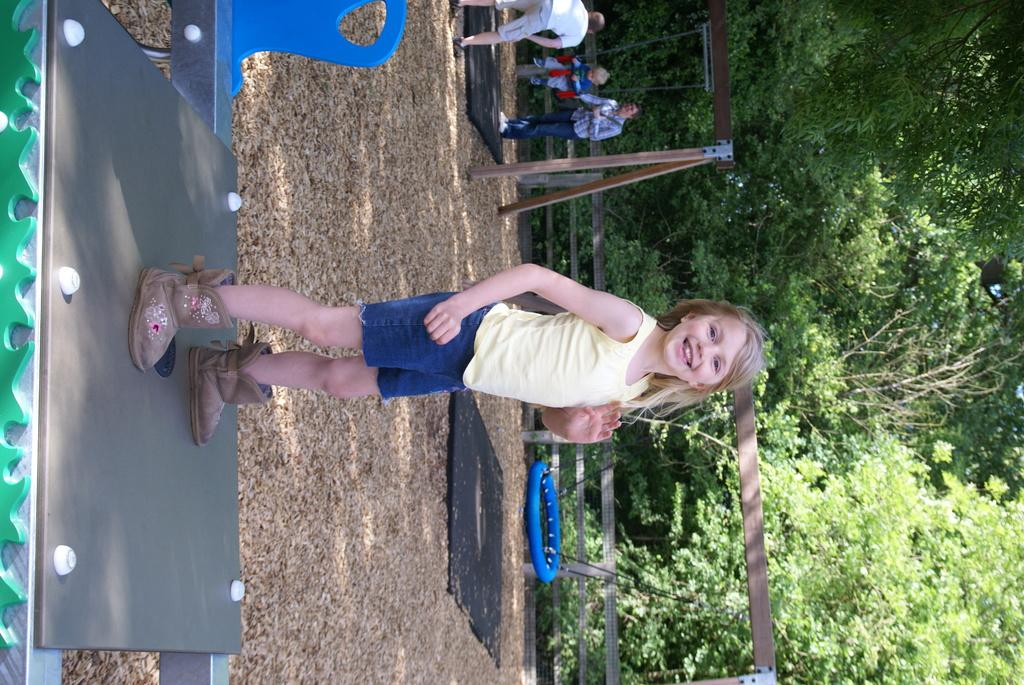What is the girl doing in the image? The girl is standing on a platform in the image. What can be seen in the background behind the girl? A: In the background, there is a fence, people, trees, and swings. Can you describe the setting of the image? The girl is standing on a platform, and there are various elements in the background, including a fence, people, trees, and swings, suggesting an outdoor recreational area. How much payment is required to use the bucket in the image? There is no bucket present in the image, so no payment is required for its use. 